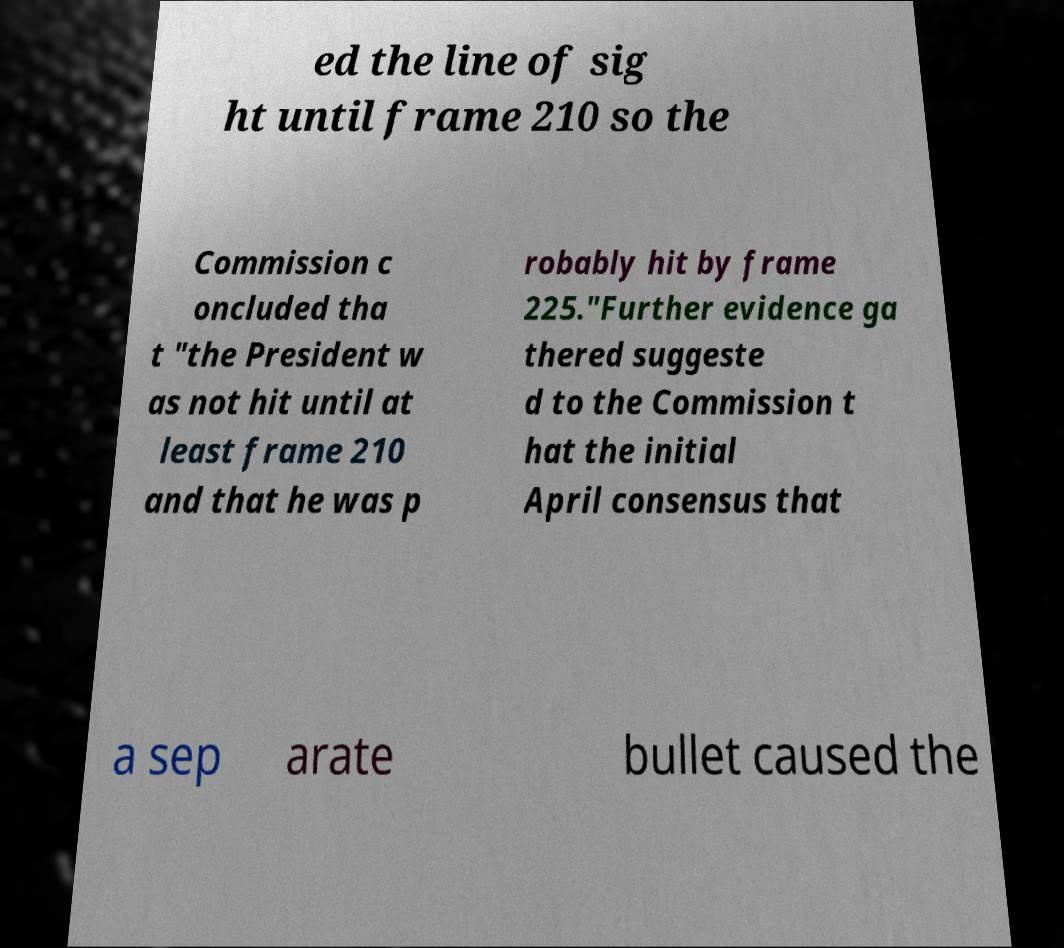I need the written content from this picture converted into text. Can you do that? ed the line of sig ht until frame 210 so the Commission c oncluded tha t "the President w as not hit until at least frame 210 and that he was p robably hit by frame 225."Further evidence ga thered suggeste d to the Commission t hat the initial April consensus that a sep arate bullet caused the 